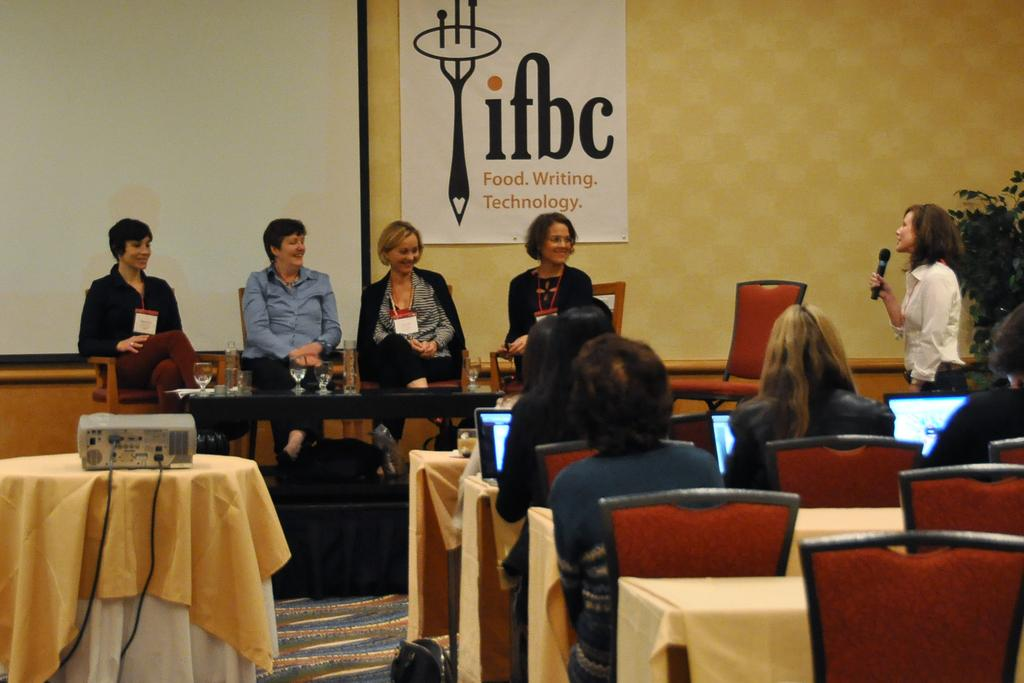How many people are in the image? There are people in the image, but the exact number is not specified. What are some of the people doing in the image? Some people are standing, and some people are sitting. What can be seen in front of the people? There are monitors in front of the people. What type of rabbit can be seen answering questions in the image? There is no rabbit present in the image, and therefore no such activity can be observed. What is the occasion being celebrated in the image? The facts provided do not mention any occasion or celebration, so it cannot be determined from the image. 